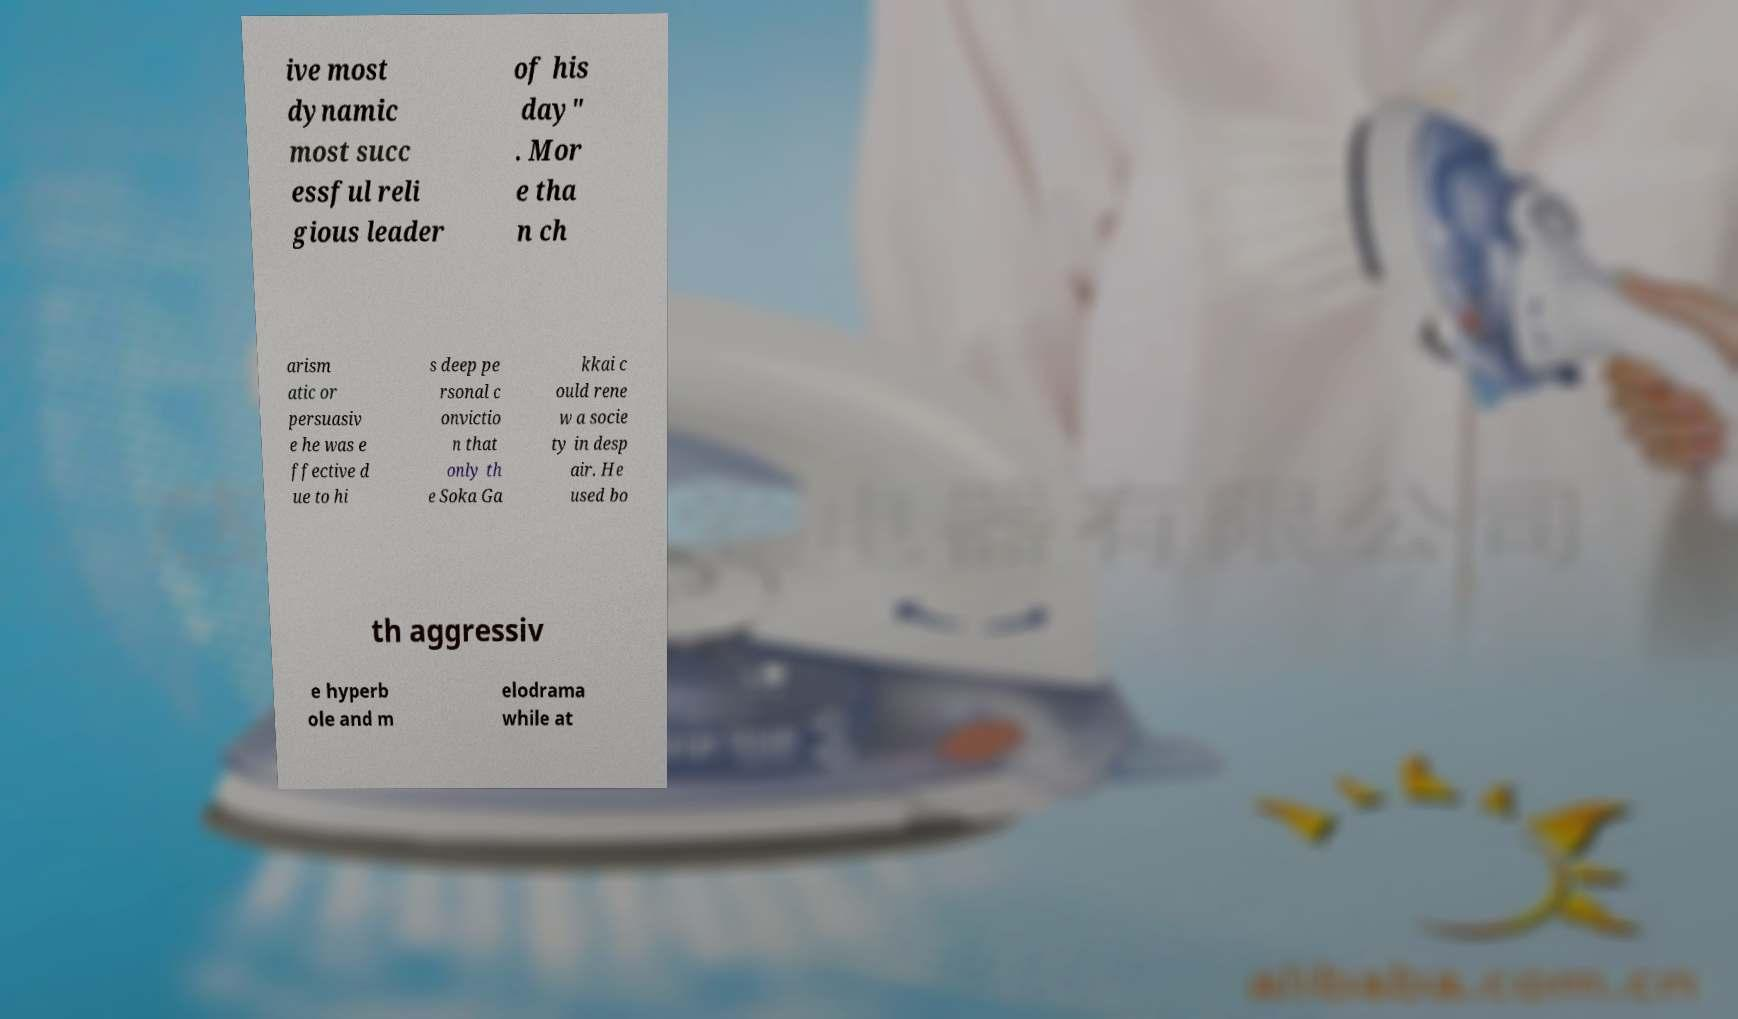There's text embedded in this image that I need extracted. Can you transcribe it verbatim? ive most dynamic most succ essful reli gious leader of his day" . Mor e tha n ch arism atic or persuasiv e he was e ffective d ue to hi s deep pe rsonal c onvictio n that only th e Soka Ga kkai c ould rene w a socie ty in desp air. He used bo th aggressiv e hyperb ole and m elodrama while at 